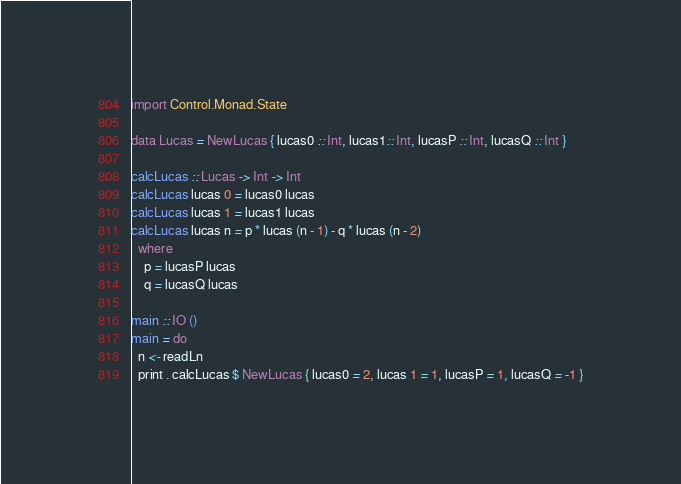<code> <loc_0><loc_0><loc_500><loc_500><_Haskell_>import Control.Monad.State

data Lucas = NewLucas { lucas0 :: Int, lucas1:: Int, lucasP :: Int, lucasQ :: Int }

calcLucas :: Lucas -> Int -> Int
calcLucas lucas 0 = lucas0 lucas
calcLucas lucas 1 = lucas1 lucas
calcLucas lucas n = p * lucas (n - 1) - q * lucas (n - 2)
  where
    p = lucasP lucas
    q = lucasQ lucas
 
main :: IO ()
main = do
  n <- readLn 
  print . calcLucas $ NewLucas { lucas0 = 2, lucas 1 = 1, lucasP = 1, lucasQ = -1 }


</code> 